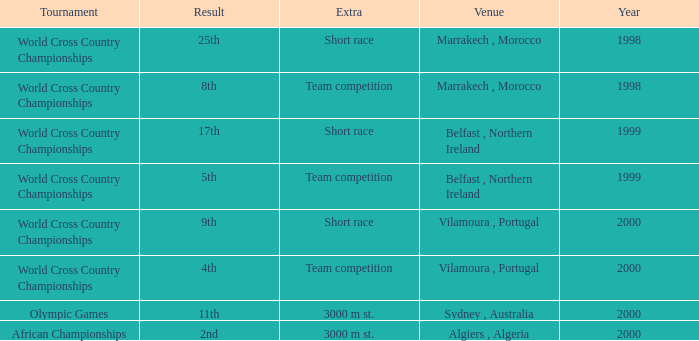Tell me the extra for tournament of olympic games 3000 m st. 